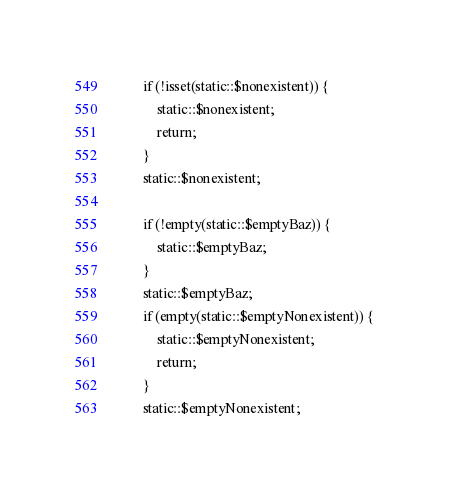Convert code to text. <code><loc_0><loc_0><loc_500><loc_500><_PHP_>		if (!isset(static::$nonexistent)) {
			static::$nonexistent;
			return;
		}
		static::$nonexistent;

		if (!empty(static::$emptyBaz)) {
			static::$emptyBaz;
		}
		static::$emptyBaz;
		if (empty(static::$emptyNonexistent)) {
			static::$emptyNonexistent;
			return;
		}
		static::$emptyNonexistent;
</code> 